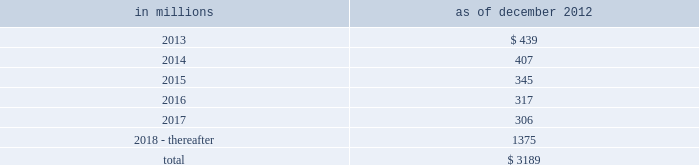Notes to consolidated financial statements sumitomo mitsui financial group , inc .
( smfg ) provides the firm with credit loss protection on certain approved loan commitments ( primarily investment-grade commercial lending commitments ) .
The notional amount of such loan commitments was $ 32.41 billion and $ 31.94 billion as of december 2012 and december 2011 , respectively .
The credit loss protection on loan commitments provided by smfg is generally limited to 95% ( 95 % ) of the first loss the firm realizes on such commitments , up to a maximum of approximately $ 950 million .
In addition , subject to the satisfaction of certain conditions , upon the firm 2019s request , smfg will provide protection for 70% ( 70 % ) of additional losses on such commitments , up to a maximum of $ 1.13 billion , of which $ 300 million of protection had been provided as of both december 2012 and december 2011 .
The firm also uses other financial instruments to mitigate credit risks related to certain commitments not covered by smfg .
These instruments primarily include credit default swaps that reference the same or similar underlying instrument or entity or credit default swaps that reference a market index .
Warehouse financing .
The firm provides financing to clients who warehouse financial assets .
These arrangements are secured by the warehoused assets , primarily consisting of commercial mortgage loans .
Contingent and forward starting resale and securities borrowing agreements/forward starting repurchase and secured lending agreements the firm enters into resale and securities borrowing agreements and repurchase and secured lending agreements that settle at a future date .
The firm also enters into commitments to provide contingent financing to its clients and counterparties through resale agreements .
The firm 2019s funding of these commitments depends on the satisfaction of all contractual conditions to the resale agreement and these commitments can expire unused .
Investment commitments the firm 2019s investment commitments consist of commitments to invest in private equity , real estate and other assets directly and through funds that the firm raises and manages .
These commitments include $ 872 million and $ 1.62 billion as of december 2012 and december 2011 , respectively , related to real estate private investments and $ 6.47 billion and $ 7.50 billion as of december 2012 and december 2011 , respectively , related to corporate and other private investments .
Of these amounts , $ 6.21 billion and $ 8.38 billion as of december 2012 and december 2011 , respectively , relate to commitments to invest in funds managed by the firm , which will be funded at market value on the date of investment .
Leases the firm has contractual obligations under long-term noncancelable lease agreements , principally for office space , expiring on various dates through 2069 .
Certain agreements are subject to periodic escalation provisions for increases in real estate taxes and other charges .
The table below presents future minimum rental payments , net of minimum sublease rentals .
In millions december 2012 .
Rent charged to operating expense for the years ended december 2012 , december 2011 and december 2010 was $ 374 million , $ 475 million and $ 508 million , respectively .
Operating leases include office space held in excess of current requirements .
Rent expense relating to space held for growth is included in 201coccupancy . 201d the firm records a liability , based on the fair value of the remaining lease rentals reduced by any potential or existing sublease rentals , for leases where the firm has ceased using the space and management has concluded that the firm will not derive any future economic benefits .
Costs to terminate a lease before the end of its term are recognized and measured at fair value on termination .
Goldman sachs 2012 annual report 175 .
What percent of future net minimum rental payments are due in 2018 and thereafter? 
Computations: (1375 / 3189)
Answer: 0.43117. 